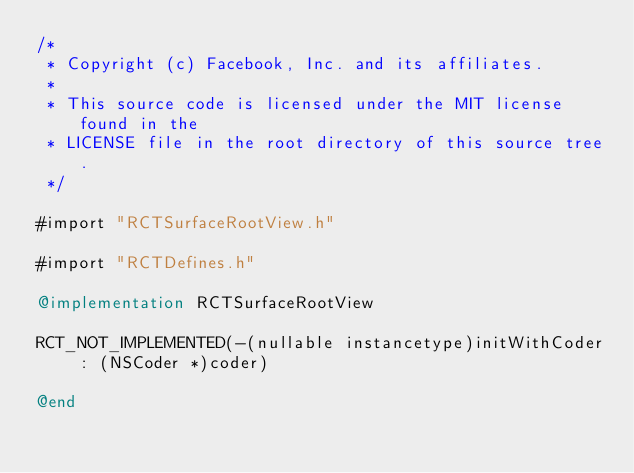Convert code to text. <code><loc_0><loc_0><loc_500><loc_500><_ObjectiveC_>/*
 * Copyright (c) Facebook, Inc. and its affiliates.
 *
 * This source code is licensed under the MIT license found in the
 * LICENSE file in the root directory of this source tree.
 */

#import "RCTSurfaceRootView.h"

#import "RCTDefines.h"

@implementation RCTSurfaceRootView

RCT_NOT_IMPLEMENTED(-(nullable instancetype)initWithCoder : (NSCoder *)coder)

@end
</code> 